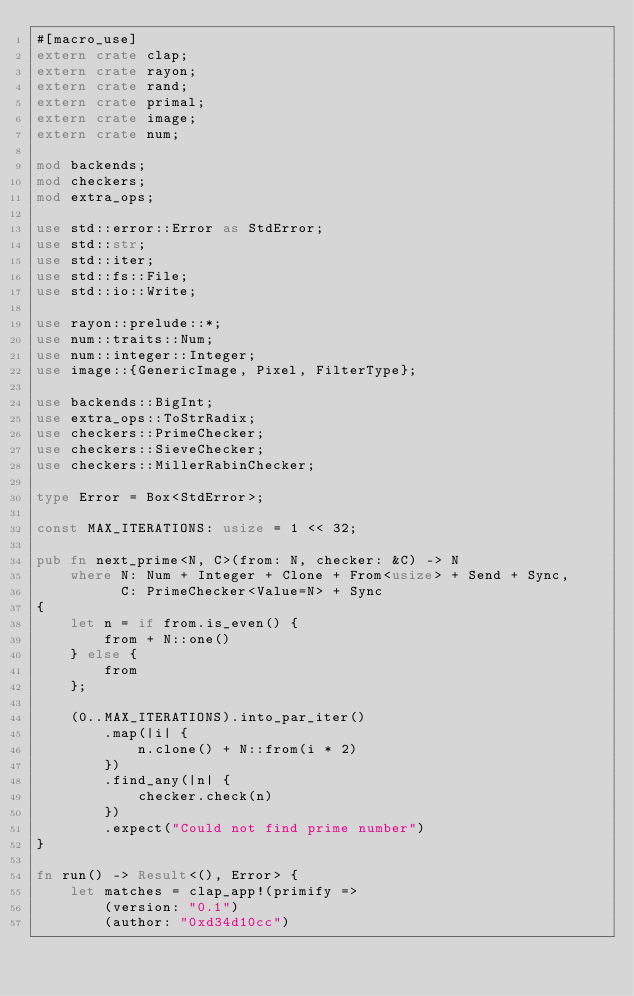Convert code to text. <code><loc_0><loc_0><loc_500><loc_500><_Rust_>#[macro_use]
extern crate clap;
extern crate rayon;
extern crate rand;
extern crate primal;
extern crate image;
extern crate num;

mod backends;
mod checkers;
mod extra_ops;

use std::error::Error as StdError;
use std::str;
use std::iter;
use std::fs::File;
use std::io::Write;

use rayon::prelude::*;
use num::traits::Num;
use num::integer::Integer;
use image::{GenericImage, Pixel, FilterType};

use backends::BigInt;
use extra_ops::ToStrRadix;
use checkers::PrimeChecker;
use checkers::SieveChecker;
use checkers::MillerRabinChecker;

type Error = Box<StdError>;

const MAX_ITERATIONS: usize = 1 << 32;

pub fn next_prime<N, C>(from: N, checker: &C) -> N 
    where N: Num + Integer + Clone + From<usize> + Send + Sync,
          C: PrimeChecker<Value=N> + Sync 
{
    let n = if from.is_even() {
        from + N::one()
    } else {
        from
    };

    (0..MAX_ITERATIONS).into_par_iter()
        .map(|i| {
            n.clone() + N::from(i * 2)
        })
        .find_any(|n| {
            checker.check(n)
        })
        .expect("Could not find prime number")
}

fn run() -> Result<(), Error> {
    let matches = clap_app!(primify =>
        (version: "0.1")
        (author: "0xd34d10cc")</code> 